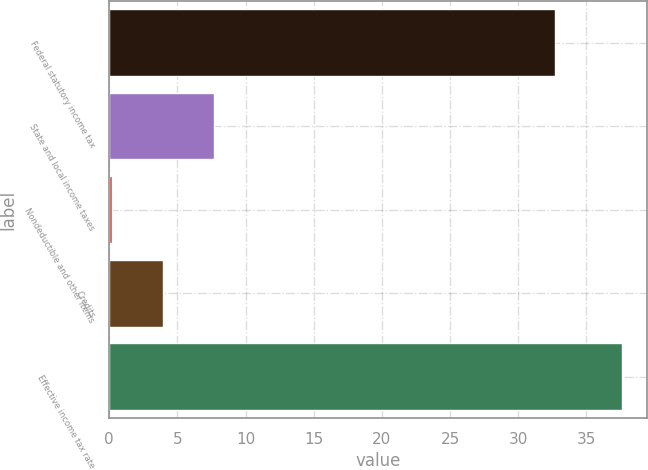Convert chart to OTSL. <chart><loc_0><loc_0><loc_500><loc_500><bar_chart><fcel>Federal statutory income tax<fcel>State and local income taxes<fcel>Nondeductible and other items<fcel>Credits<fcel>Effective income tax rate<nl><fcel>32.7<fcel>7.68<fcel>0.2<fcel>3.94<fcel>37.6<nl></chart> 